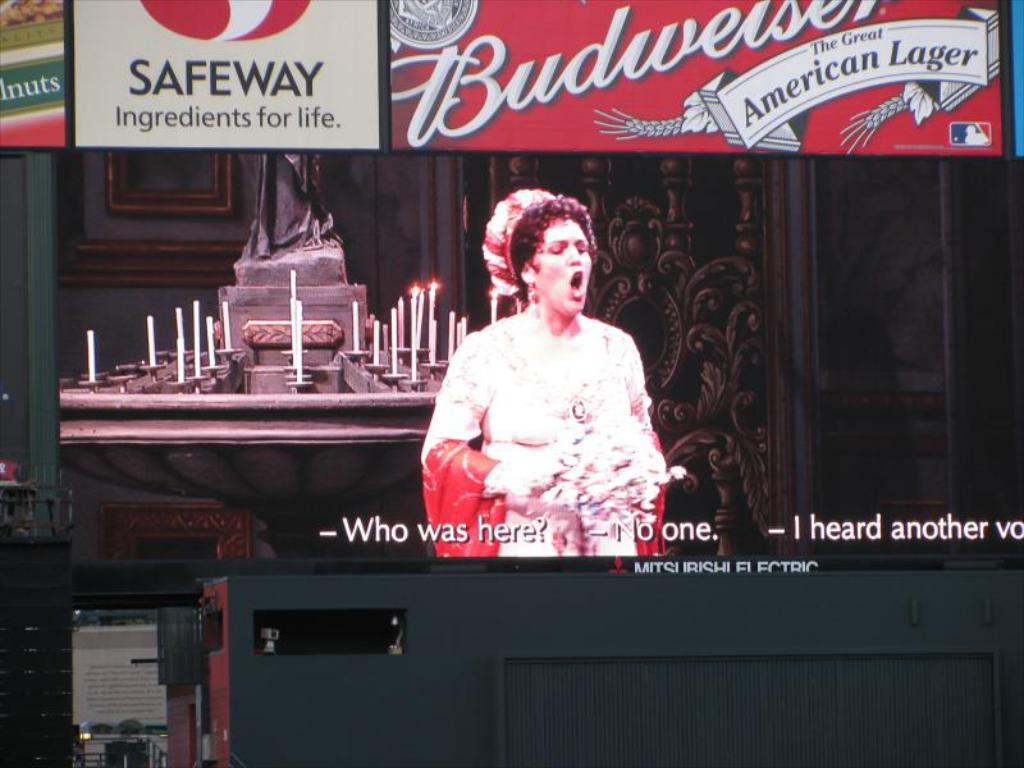What is the main subject of the image? There is a woman standing in the image. What can be seen in the background of the image? There are candles and boards with writing in the background of the image. Is there any text visible on the image? Yes, there is text visible on the image. What type of jeans is the woman wearing in the image? The image does not provide information about the woman's clothing, so it cannot be determined if she is wearing jeans or any other type of clothing. What thought is the woman having in the image? The image does not provide any information about the woman's thoughts or emotions, so it cannot be determined what she might be thinking. 